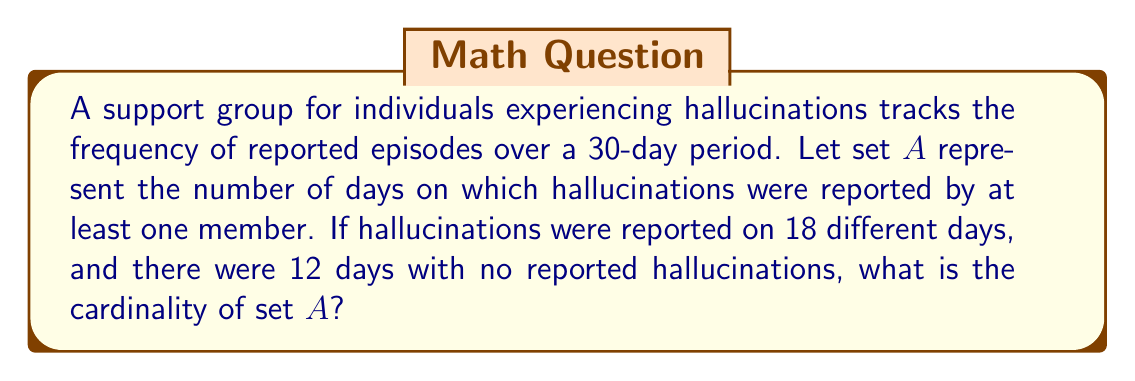Teach me how to tackle this problem. To solve this problem, we need to understand the concept of cardinality in set theory and apply it to the given scenario. The cardinality of a set is the number of elements in the set.

Let's break down the information given:
1. The time period is 30 days.
2. Hallucinations were reported on 18 different days.
3. There were 12 days with no reported hallucinations.

Set $A$ represents the number of days on which hallucinations were reported. To find its cardinality, we need to count the number of elements (days) in this set.

We can calculate this in two ways:

Method 1: Direct count
The question states that hallucinations were reported on 18 different days. This directly gives us the cardinality of set $A$.

Method 2: Complement method
We can also find the cardinality by subtracting the number of days without hallucinations from the total number of days:

$|A| = \text{Total days} - \text{Days without hallucinations}$
$|A| = 30 - 12 = 18$

Both methods yield the same result: the cardinality of set $A$ is 18.

In set notation, we would write this as:

$|A| = 18$

where $|A|$ denotes the cardinality of set $A$.
Answer: $|A| = 18$ 